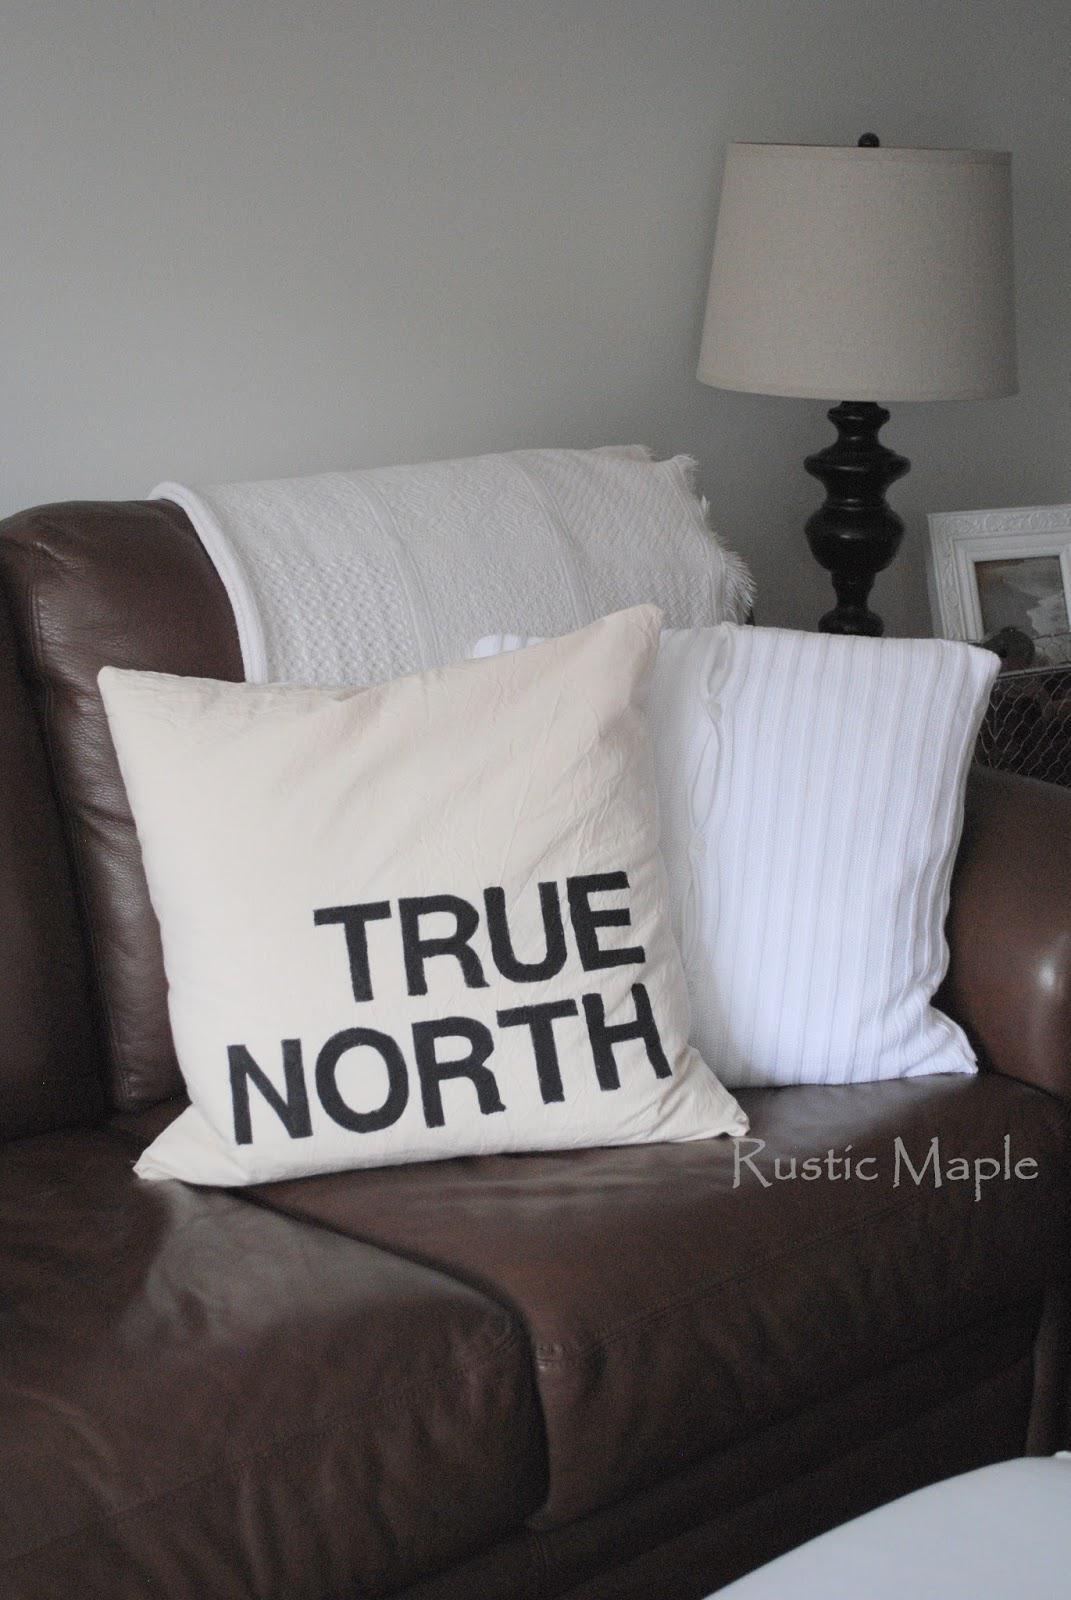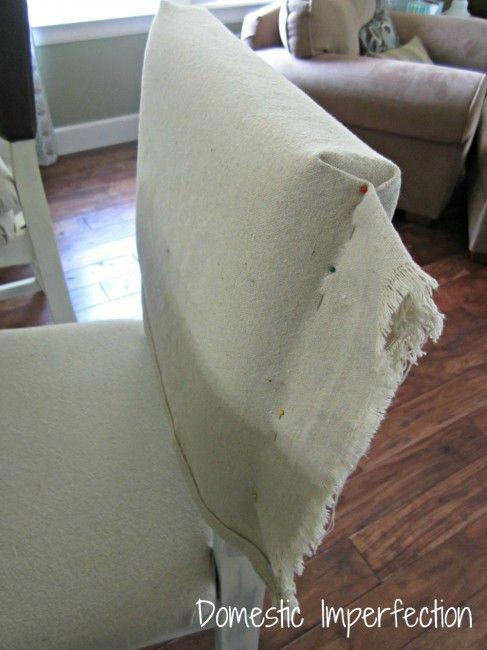The first image is the image on the left, the second image is the image on the right. Evaluate the accuracy of this statement regarding the images: "Pillows in each image have printed images or words on them.". Is it true? Answer yes or no. No. The first image is the image on the left, the second image is the image on the right. Given the left and right images, does the statement "There are two pillow on top of a brown surface." hold true? Answer yes or no. Yes. 